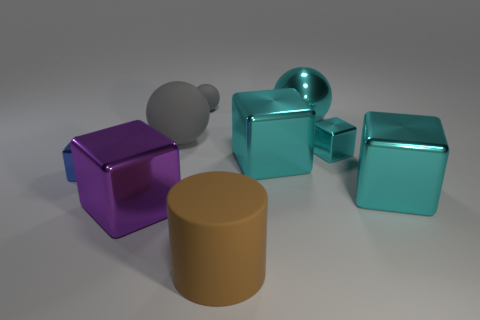If these objects were part of a puzzle, what might be the goal for solving it? One possible goal could be to arrange the objects by size or color gradients, or perhaps to fit the smaller objects into or onto the larger ones in a way that follows a specific rule or pattern. 